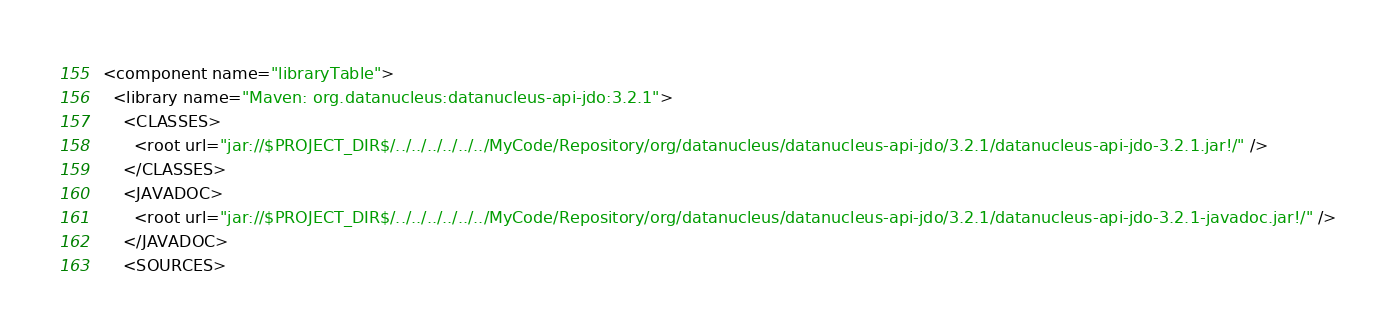<code> <loc_0><loc_0><loc_500><loc_500><_XML_><component name="libraryTable">
  <library name="Maven: org.datanucleus:datanucleus-api-jdo:3.2.1">
    <CLASSES>
      <root url="jar://$PROJECT_DIR$/../../../../../../MyCode/Repository/org/datanucleus/datanucleus-api-jdo/3.2.1/datanucleus-api-jdo-3.2.1.jar!/" />
    </CLASSES>
    <JAVADOC>
      <root url="jar://$PROJECT_DIR$/../../../../../../MyCode/Repository/org/datanucleus/datanucleus-api-jdo/3.2.1/datanucleus-api-jdo-3.2.1-javadoc.jar!/" />
    </JAVADOC>
    <SOURCES></code> 